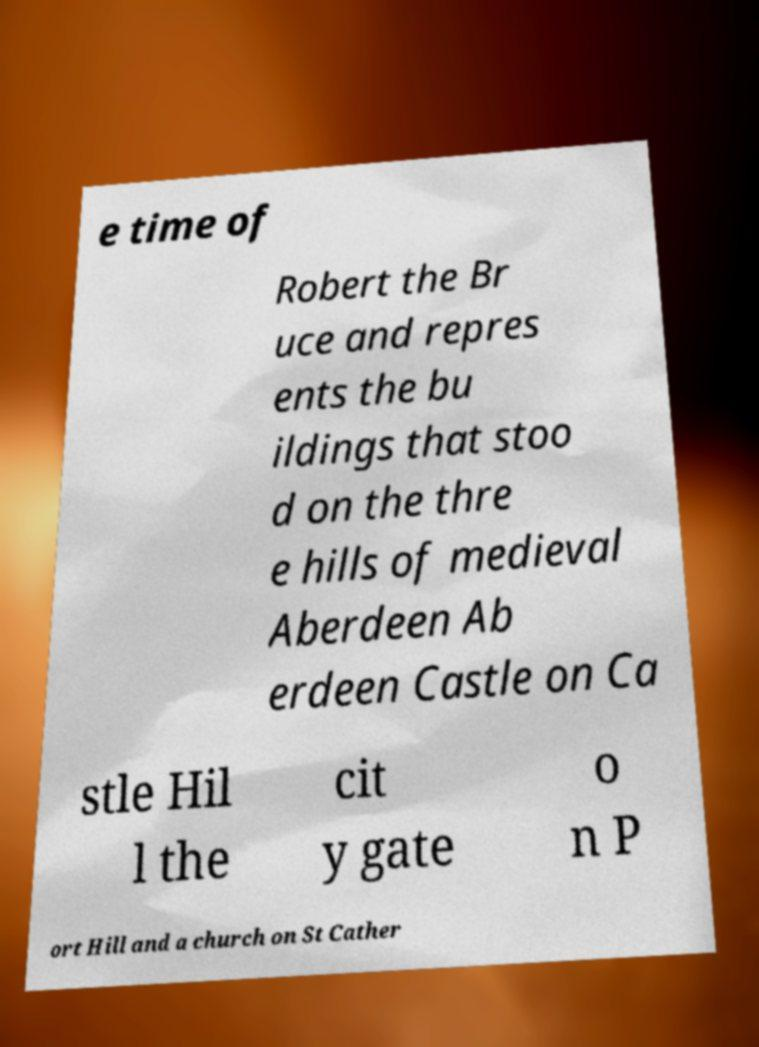Please identify and transcribe the text found in this image. e time of Robert the Br uce and repres ents the bu ildings that stoo d on the thre e hills of medieval Aberdeen Ab erdeen Castle on Ca stle Hil l the cit y gate o n P ort Hill and a church on St Cather 